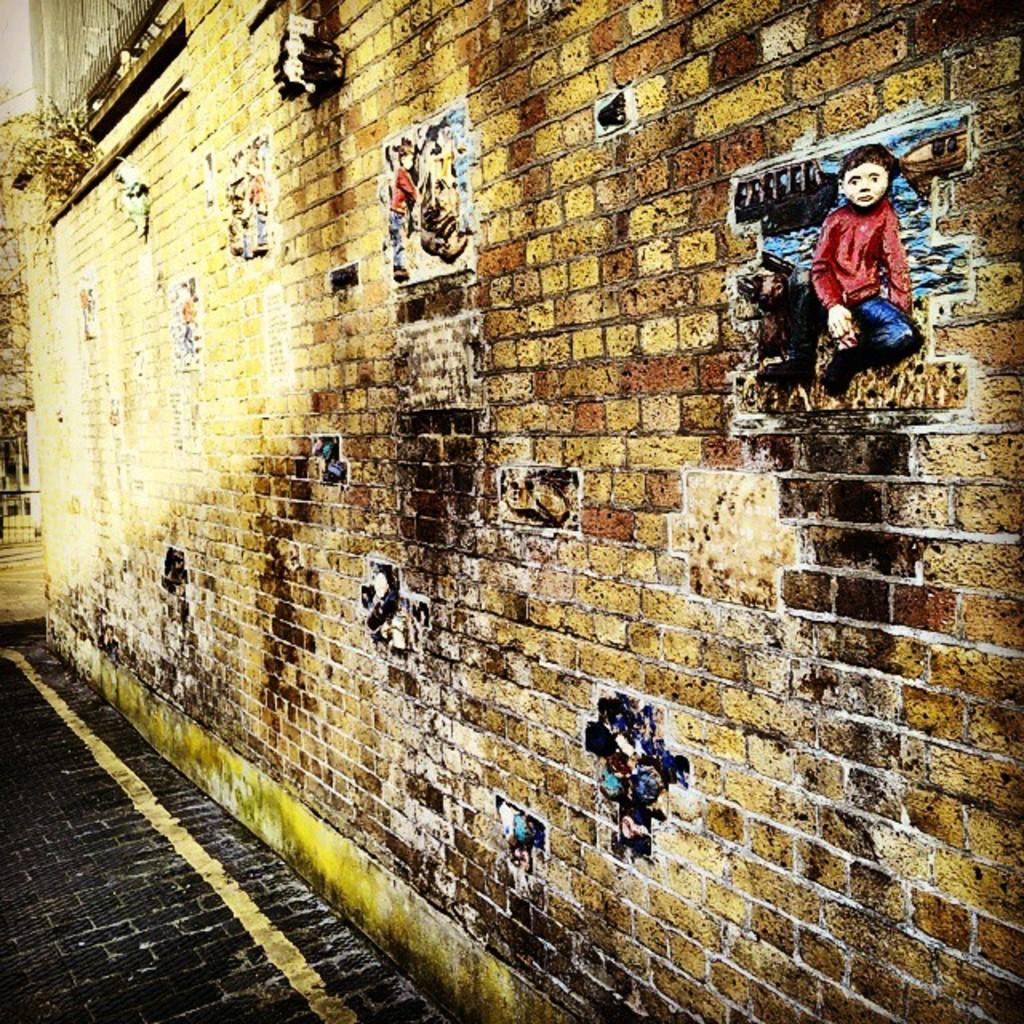What type of surface can be seen in the image? There is ground visible in the image. What structures are present on the wall in the image? There are posts on a wall in the image. What type of teeth can be seen on the pet in the image? There is no pet present in the image, and therefore no teeth cannot be observed. 